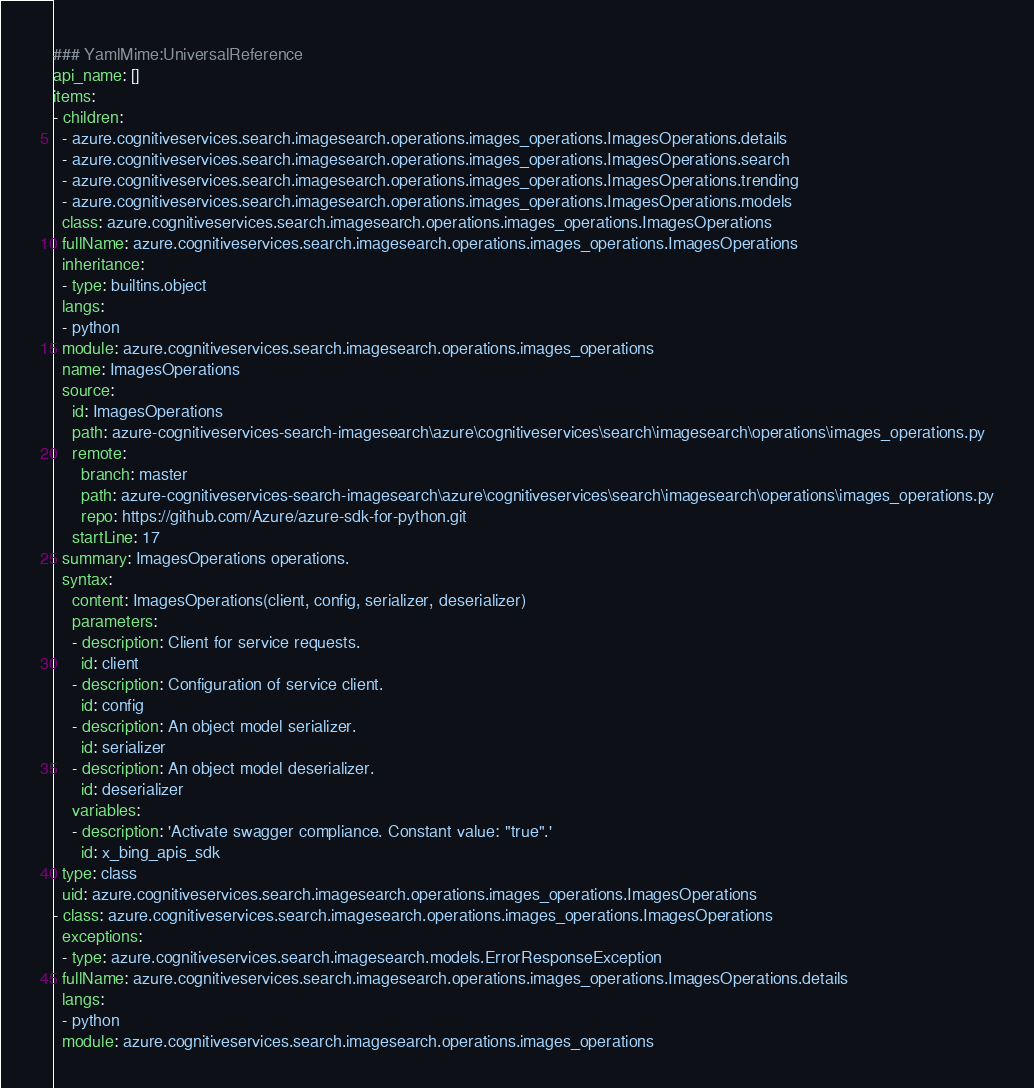<code> <loc_0><loc_0><loc_500><loc_500><_YAML_>### YamlMime:UniversalReference
api_name: []
items:
- children:
  - azure.cognitiveservices.search.imagesearch.operations.images_operations.ImagesOperations.details
  - azure.cognitiveservices.search.imagesearch.operations.images_operations.ImagesOperations.search
  - azure.cognitiveservices.search.imagesearch.operations.images_operations.ImagesOperations.trending
  - azure.cognitiveservices.search.imagesearch.operations.images_operations.ImagesOperations.models
  class: azure.cognitiveservices.search.imagesearch.operations.images_operations.ImagesOperations
  fullName: azure.cognitiveservices.search.imagesearch.operations.images_operations.ImagesOperations
  inheritance:
  - type: builtins.object
  langs:
  - python
  module: azure.cognitiveservices.search.imagesearch.operations.images_operations
  name: ImagesOperations
  source:
    id: ImagesOperations
    path: azure-cognitiveservices-search-imagesearch\azure\cognitiveservices\search\imagesearch\operations\images_operations.py
    remote:
      branch: master
      path: azure-cognitiveservices-search-imagesearch\azure\cognitiveservices\search\imagesearch\operations\images_operations.py
      repo: https://github.com/Azure/azure-sdk-for-python.git
    startLine: 17
  summary: ImagesOperations operations.
  syntax:
    content: ImagesOperations(client, config, serializer, deserializer)
    parameters:
    - description: Client for service requests.
      id: client
    - description: Configuration of service client.
      id: config
    - description: An object model serializer.
      id: serializer
    - description: An object model deserializer.
      id: deserializer
    variables:
    - description: 'Activate swagger compliance. Constant value: "true".'
      id: x_bing_apis_sdk
  type: class
  uid: azure.cognitiveservices.search.imagesearch.operations.images_operations.ImagesOperations
- class: azure.cognitiveservices.search.imagesearch.operations.images_operations.ImagesOperations
  exceptions:
  - type: azure.cognitiveservices.search.imagesearch.models.ErrorResponseException
  fullName: azure.cognitiveservices.search.imagesearch.operations.images_operations.ImagesOperations.details
  langs:
  - python
  module: azure.cognitiveservices.search.imagesearch.operations.images_operations</code> 